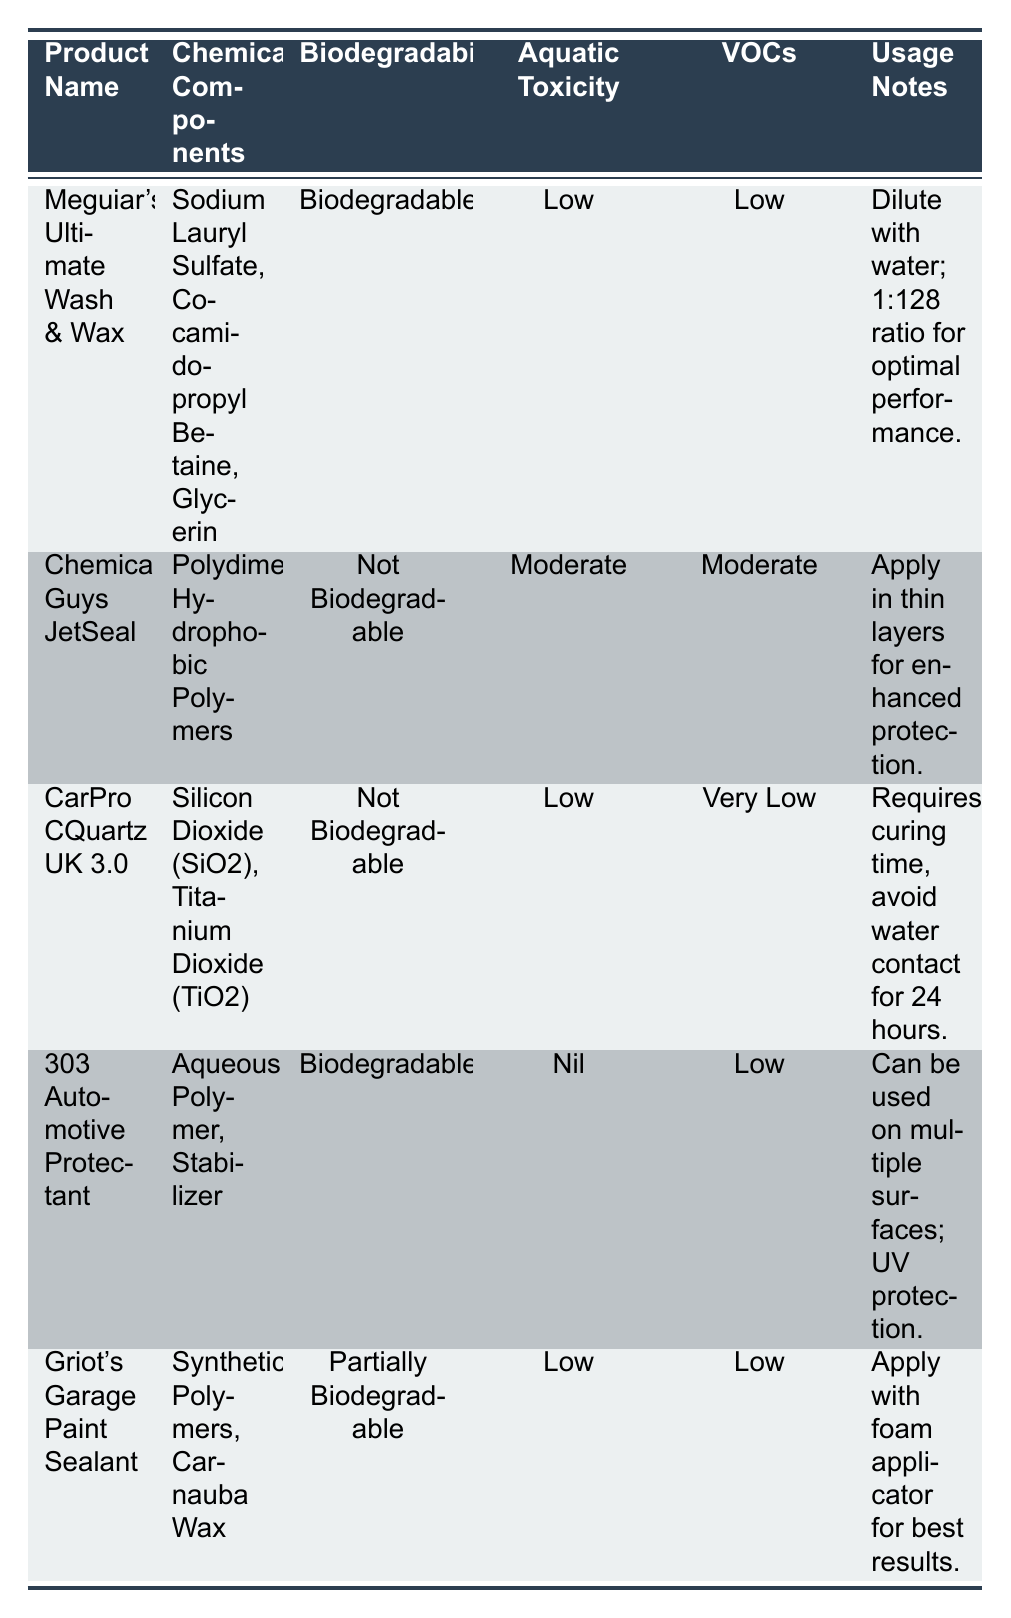What is the biodegradability of CarPro CQuartz UK 3.0? CarPro CQuartz UK 3.0 is listed under the "Biodegradability" column, which states "Not Biodegradable."
Answer: Not Biodegradable Which car detailing product has the lowest aquatic toxicity? The "Aquatic Toxicity" column shows values for each product. 303 Automotive Protectant has "Nil," which is lower than the other products (Meguiar's is Low, Chemical Guys JetSeal is Moderate, and Griot's Garage Paint Sealant is Low).
Answer: 303 Automotive Protectant How many products are biodegradable? The "Biodegradability" column lists two products as biodegradable: Meguiar's Ultimate Wash & Wax and 303 Automotive Protectant. Therefore, the count of biodegradable products is 2.
Answer: 2 Are there any products that have low volatile organic compounds? From the "VOCs" column, it can be observed that Meguiar's Ultimate Wash & Wax, 303 Automotive Protectant, and Griot's Garage Paint Sealant are all listed with "Low" VOCs. Therefore, the answer is yes.
Answer: Yes What is the environmental impact concerning VOCs for Chemical Guys JetSeal compared to Meguiar's Ultimate Wash & Wax? The "VOCs" column states that Chemical Guys JetSeal has "Moderate" VOCs while Meguiar's Ultimate Wash & Wax has "Low" VOCs. Since moderate is a higher value than low, Meguiar's Ultimate Wash & Wax has less environmental impact regarding VOCs.
Answer: Meguiar's Ultimate Wash & Wax has a lower environmental impact regarding VOCs 